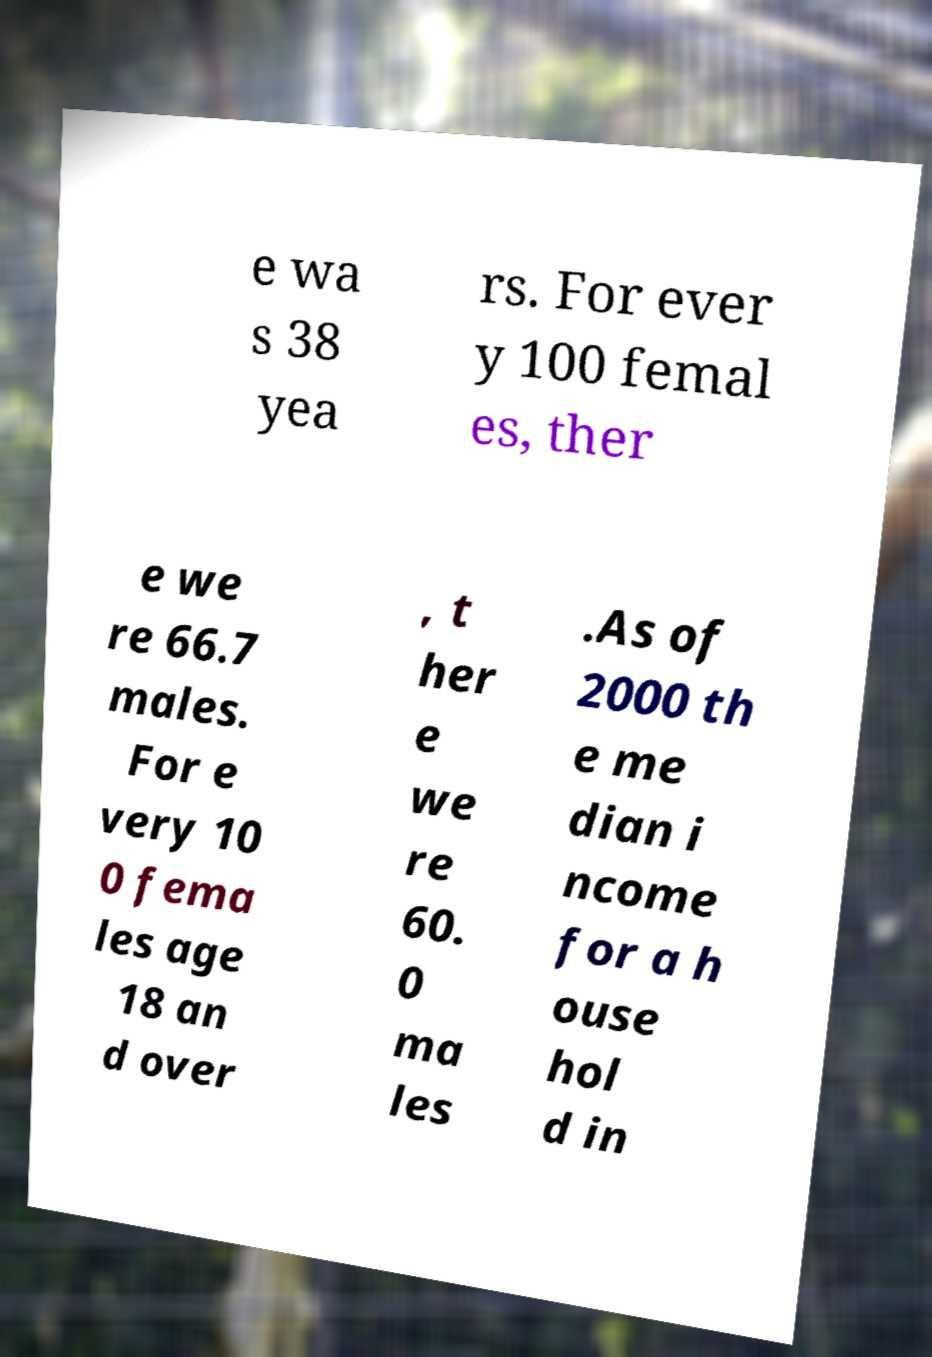Please read and relay the text visible in this image. What does it say? e wa s 38 yea rs. For ever y 100 femal es, ther e we re 66.7 males. For e very 10 0 fema les age 18 an d over , t her e we re 60. 0 ma les .As of 2000 th e me dian i ncome for a h ouse hol d in 